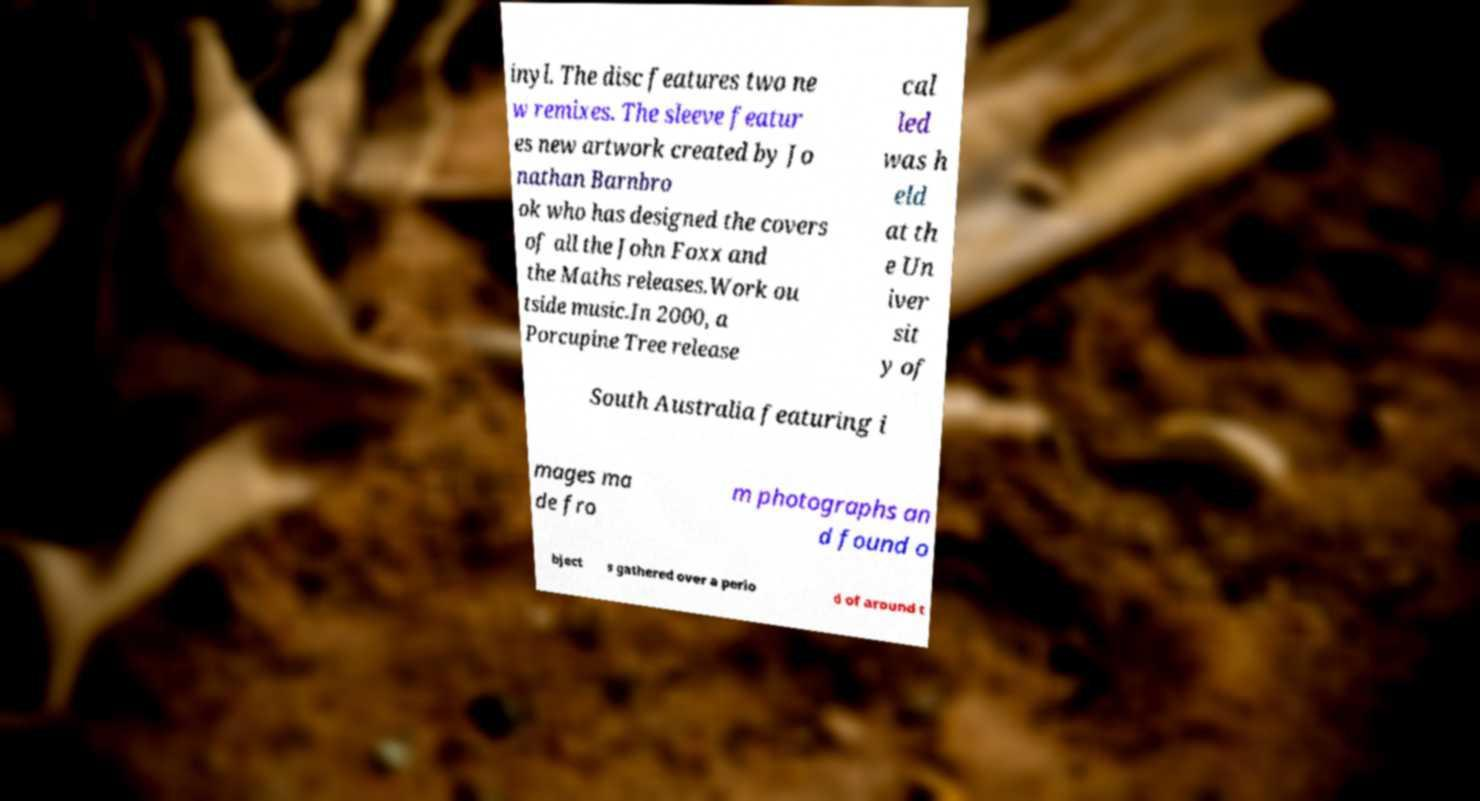Can you accurately transcribe the text from the provided image for me? inyl. The disc features two ne w remixes. The sleeve featur es new artwork created by Jo nathan Barnbro ok who has designed the covers of all the John Foxx and the Maths releases.Work ou tside music.In 2000, a Porcupine Tree release cal led was h eld at th e Un iver sit y of South Australia featuring i mages ma de fro m photographs an d found o bject s gathered over a perio d of around t 